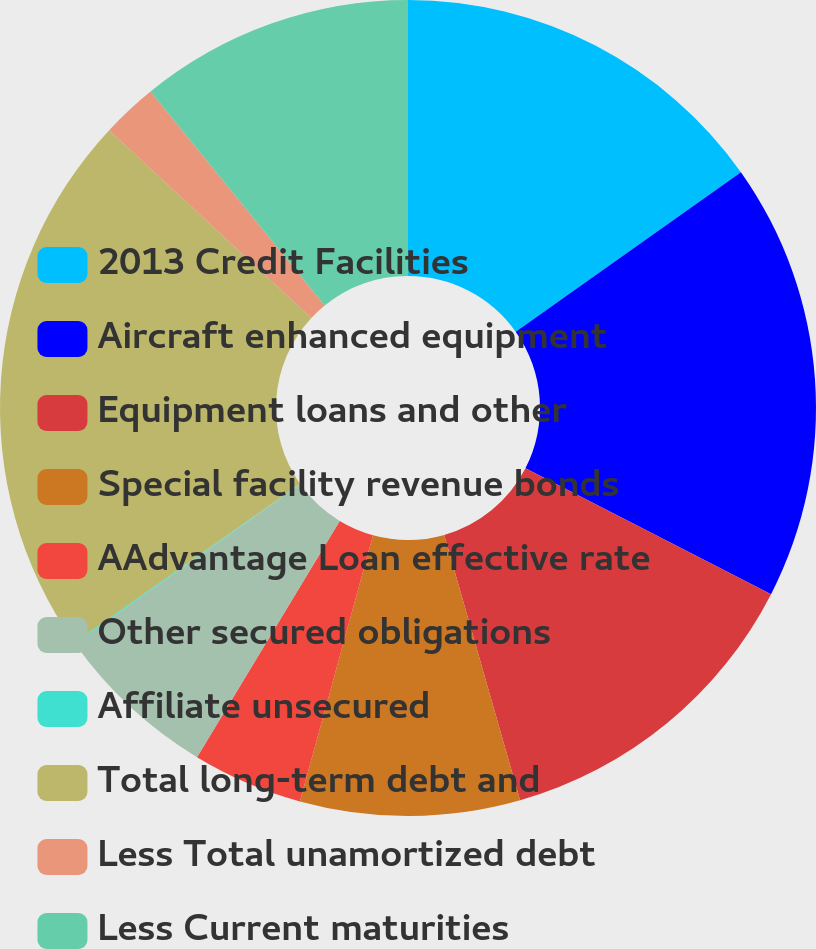<chart> <loc_0><loc_0><loc_500><loc_500><pie_chart><fcel>2013 Credit Facilities<fcel>Aircraft enhanced equipment<fcel>Equipment loans and other<fcel>Special facility revenue bonds<fcel>AAdvantage Loan effective rate<fcel>Other secured obligations<fcel>Affiliate unsecured<fcel>Total long-term debt and<fcel>Less Total unamortized debt<fcel>Less Current maturities<nl><fcel>15.19%<fcel>17.35%<fcel>13.03%<fcel>8.7%<fcel>4.38%<fcel>6.54%<fcel>0.05%<fcel>21.68%<fcel>2.21%<fcel>10.87%<nl></chart> 